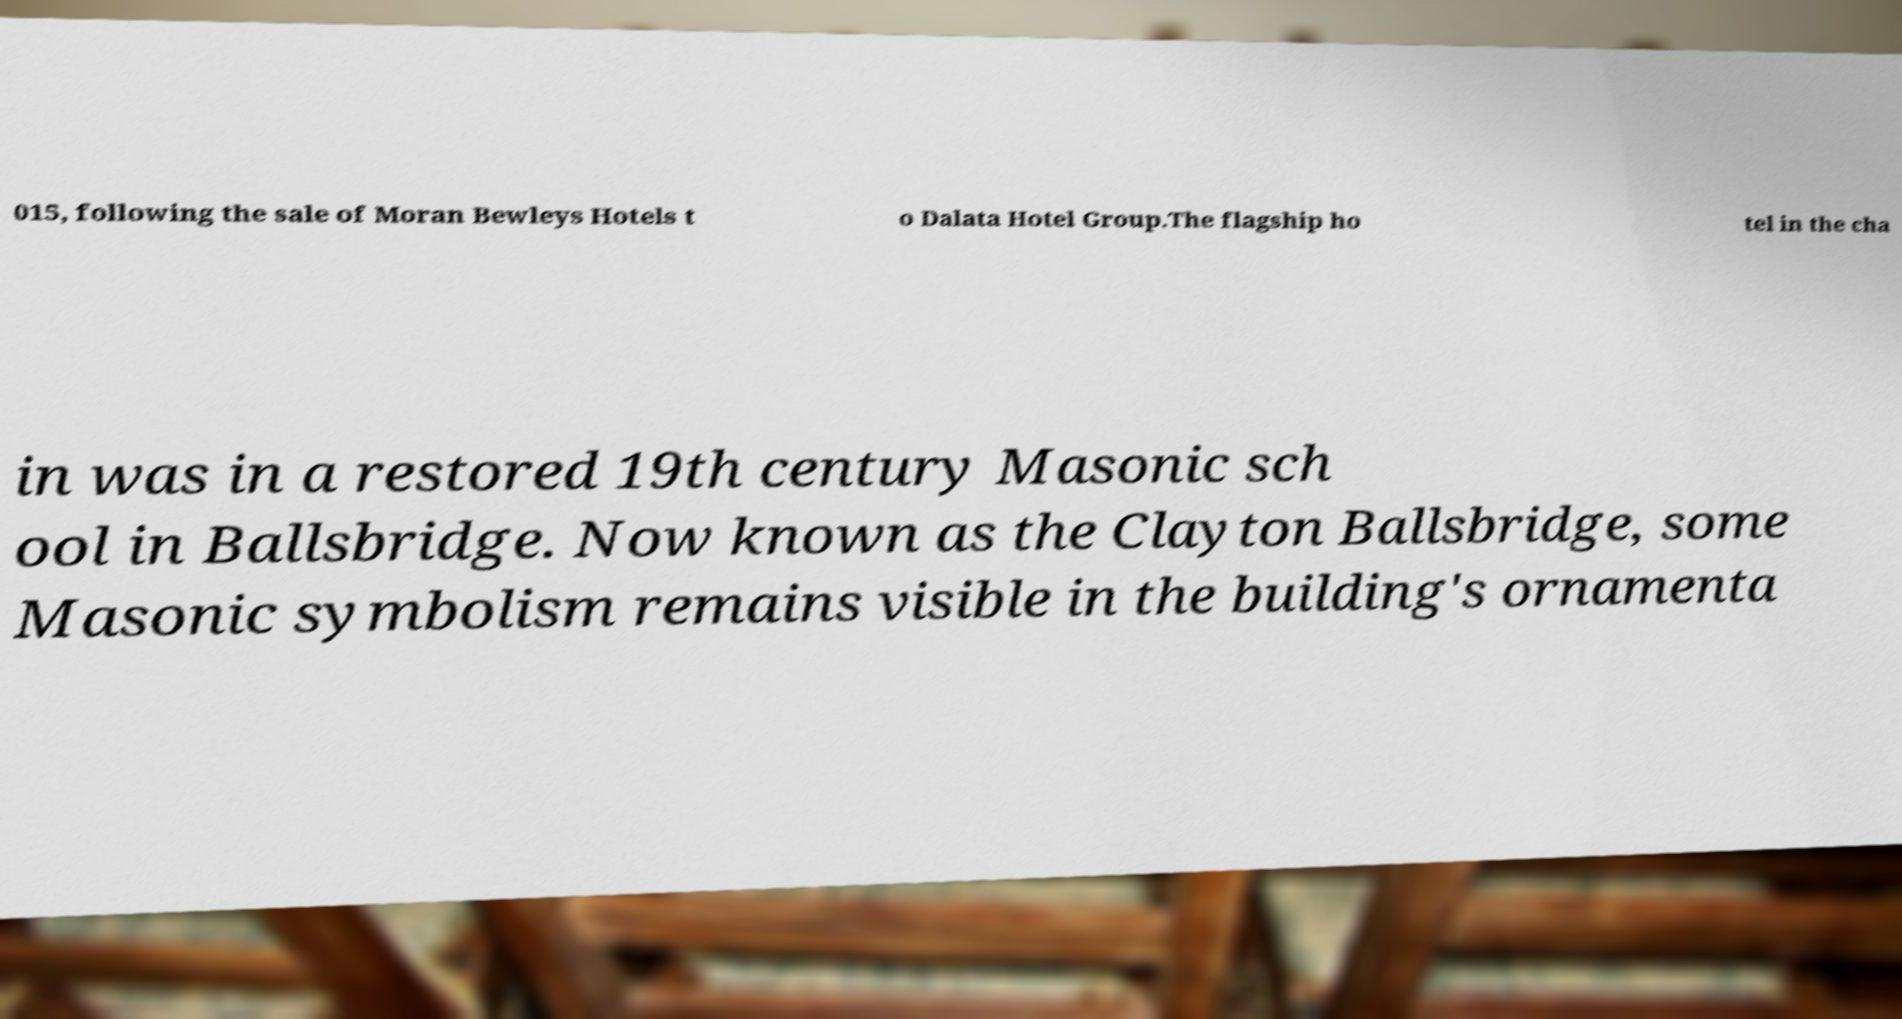There's text embedded in this image that I need extracted. Can you transcribe it verbatim? 015, following the sale of Moran Bewleys Hotels t o Dalata Hotel Group.The flagship ho tel in the cha in was in a restored 19th century Masonic sch ool in Ballsbridge. Now known as the Clayton Ballsbridge, some Masonic symbolism remains visible in the building's ornamenta 